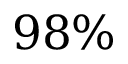<formula> <loc_0><loc_0><loc_500><loc_500>9 8 \%</formula> 